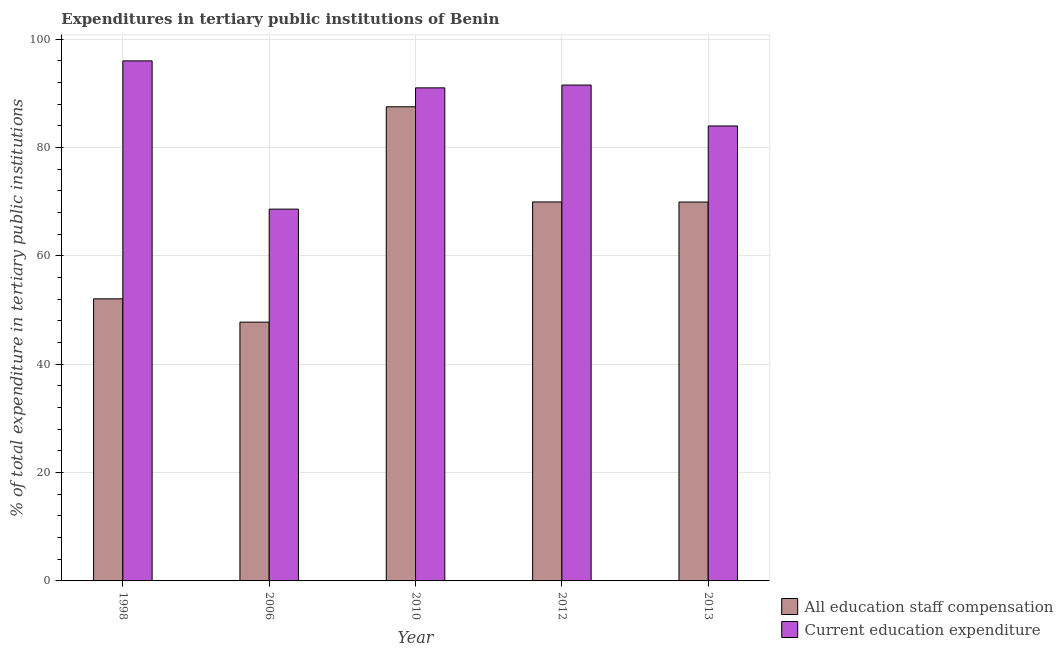How many different coloured bars are there?
Provide a short and direct response. 2. Are the number of bars per tick equal to the number of legend labels?
Provide a succinct answer. Yes. Are the number of bars on each tick of the X-axis equal?
Provide a short and direct response. Yes. In how many cases, is the number of bars for a given year not equal to the number of legend labels?
Provide a succinct answer. 0. What is the expenditure in education in 2012?
Ensure brevity in your answer.  91.56. Across all years, what is the maximum expenditure in staff compensation?
Offer a terse response. 87.55. Across all years, what is the minimum expenditure in staff compensation?
Provide a short and direct response. 47.78. In which year was the expenditure in staff compensation maximum?
Your answer should be very brief. 2010. In which year was the expenditure in staff compensation minimum?
Provide a short and direct response. 2006. What is the total expenditure in education in the graph?
Offer a very short reply. 431.26. What is the difference between the expenditure in education in 1998 and that in 2006?
Ensure brevity in your answer.  27.37. What is the difference between the expenditure in education in 2013 and the expenditure in staff compensation in 2010?
Provide a short and direct response. -7.04. What is the average expenditure in education per year?
Provide a succinct answer. 86.25. In the year 2006, what is the difference between the expenditure in education and expenditure in staff compensation?
Keep it short and to the point. 0. What is the ratio of the expenditure in staff compensation in 1998 to that in 2006?
Your response must be concise. 1.09. Is the difference between the expenditure in staff compensation in 2010 and 2012 greater than the difference between the expenditure in education in 2010 and 2012?
Offer a very short reply. No. What is the difference between the highest and the second highest expenditure in staff compensation?
Make the answer very short. 17.57. What is the difference between the highest and the lowest expenditure in education?
Give a very brief answer. 27.37. In how many years, is the expenditure in education greater than the average expenditure in education taken over all years?
Offer a terse response. 3. What does the 1st bar from the left in 2012 represents?
Make the answer very short. All education staff compensation. What does the 1st bar from the right in 2013 represents?
Provide a short and direct response. Current education expenditure. How many bars are there?
Offer a very short reply. 10. Are all the bars in the graph horizontal?
Offer a very short reply. No. How many years are there in the graph?
Your answer should be very brief. 5. What is the difference between two consecutive major ticks on the Y-axis?
Your response must be concise. 20. Does the graph contain any zero values?
Your response must be concise. No. Where does the legend appear in the graph?
Your response must be concise. Bottom right. How are the legend labels stacked?
Ensure brevity in your answer.  Vertical. What is the title of the graph?
Your answer should be very brief. Expenditures in tertiary public institutions of Benin. What is the label or title of the X-axis?
Keep it short and to the point. Year. What is the label or title of the Y-axis?
Give a very brief answer. % of total expenditure in tertiary public institutions. What is the % of total expenditure in tertiary public institutions of All education staff compensation in 1998?
Ensure brevity in your answer.  52.09. What is the % of total expenditure in tertiary public institutions of Current education expenditure in 1998?
Make the answer very short. 96.02. What is the % of total expenditure in tertiary public institutions in All education staff compensation in 2006?
Keep it short and to the point. 47.78. What is the % of total expenditure in tertiary public institutions of Current education expenditure in 2006?
Give a very brief answer. 68.65. What is the % of total expenditure in tertiary public institutions of All education staff compensation in 2010?
Keep it short and to the point. 87.55. What is the % of total expenditure in tertiary public institutions in Current education expenditure in 2010?
Offer a very short reply. 91.04. What is the % of total expenditure in tertiary public institutions in All education staff compensation in 2012?
Offer a very short reply. 69.98. What is the % of total expenditure in tertiary public institutions in Current education expenditure in 2012?
Ensure brevity in your answer.  91.56. What is the % of total expenditure in tertiary public institutions of All education staff compensation in 2013?
Make the answer very short. 69.96. What is the % of total expenditure in tertiary public institutions of Current education expenditure in 2013?
Provide a succinct answer. 84. Across all years, what is the maximum % of total expenditure in tertiary public institutions of All education staff compensation?
Your answer should be very brief. 87.55. Across all years, what is the maximum % of total expenditure in tertiary public institutions in Current education expenditure?
Ensure brevity in your answer.  96.02. Across all years, what is the minimum % of total expenditure in tertiary public institutions of All education staff compensation?
Give a very brief answer. 47.78. Across all years, what is the minimum % of total expenditure in tertiary public institutions in Current education expenditure?
Make the answer very short. 68.65. What is the total % of total expenditure in tertiary public institutions in All education staff compensation in the graph?
Your answer should be compact. 327.35. What is the total % of total expenditure in tertiary public institutions of Current education expenditure in the graph?
Make the answer very short. 431.26. What is the difference between the % of total expenditure in tertiary public institutions of All education staff compensation in 1998 and that in 2006?
Make the answer very short. 4.3. What is the difference between the % of total expenditure in tertiary public institutions in Current education expenditure in 1998 and that in 2006?
Offer a terse response. 27.37. What is the difference between the % of total expenditure in tertiary public institutions of All education staff compensation in 1998 and that in 2010?
Your response must be concise. -35.46. What is the difference between the % of total expenditure in tertiary public institutions of Current education expenditure in 1998 and that in 2010?
Your response must be concise. 4.98. What is the difference between the % of total expenditure in tertiary public institutions in All education staff compensation in 1998 and that in 2012?
Provide a succinct answer. -17.89. What is the difference between the % of total expenditure in tertiary public institutions of Current education expenditure in 1998 and that in 2012?
Keep it short and to the point. 4.47. What is the difference between the % of total expenditure in tertiary public institutions of All education staff compensation in 1998 and that in 2013?
Provide a succinct answer. -17.87. What is the difference between the % of total expenditure in tertiary public institutions of Current education expenditure in 1998 and that in 2013?
Your answer should be very brief. 12.02. What is the difference between the % of total expenditure in tertiary public institutions of All education staff compensation in 2006 and that in 2010?
Your answer should be compact. -39.76. What is the difference between the % of total expenditure in tertiary public institutions in Current education expenditure in 2006 and that in 2010?
Provide a short and direct response. -22.39. What is the difference between the % of total expenditure in tertiary public institutions in All education staff compensation in 2006 and that in 2012?
Offer a very short reply. -22.19. What is the difference between the % of total expenditure in tertiary public institutions of Current education expenditure in 2006 and that in 2012?
Provide a succinct answer. -22.91. What is the difference between the % of total expenditure in tertiary public institutions in All education staff compensation in 2006 and that in 2013?
Your response must be concise. -22.17. What is the difference between the % of total expenditure in tertiary public institutions in Current education expenditure in 2006 and that in 2013?
Offer a very short reply. -15.36. What is the difference between the % of total expenditure in tertiary public institutions of All education staff compensation in 2010 and that in 2012?
Your answer should be compact. 17.57. What is the difference between the % of total expenditure in tertiary public institutions of Current education expenditure in 2010 and that in 2012?
Offer a terse response. -0.52. What is the difference between the % of total expenditure in tertiary public institutions in All education staff compensation in 2010 and that in 2013?
Give a very brief answer. 17.59. What is the difference between the % of total expenditure in tertiary public institutions of Current education expenditure in 2010 and that in 2013?
Your response must be concise. 7.04. What is the difference between the % of total expenditure in tertiary public institutions of All education staff compensation in 2012 and that in 2013?
Provide a succinct answer. 0.02. What is the difference between the % of total expenditure in tertiary public institutions in Current education expenditure in 2012 and that in 2013?
Ensure brevity in your answer.  7.55. What is the difference between the % of total expenditure in tertiary public institutions of All education staff compensation in 1998 and the % of total expenditure in tertiary public institutions of Current education expenditure in 2006?
Provide a short and direct response. -16.56. What is the difference between the % of total expenditure in tertiary public institutions in All education staff compensation in 1998 and the % of total expenditure in tertiary public institutions in Current education expenditure in 2010?
Make the answer very short. -38.95. What is the difference between the % of total expenditure in tertiary public institutions in All education staff compensation in 1998 and the % of total expenditure in tertiary public institutions in Current education expenditure in 2012?
Give a very brief answer. -39.47. What is the difference between the % of total expenditure in tertiary public institutions in All education staff compensation in 1998 and the % of total expenditure in tertiary public institutions in Current education expenditure in 2013?
Your answer should be compact. -31.91. What is the difference between the % of total expenditure in tertiary public institutions in All education staff compensation in 2006 and the % of total expenditure in tertiary public institutions in Current education expenditure in 2010?
Give a very brief answer. -43.25. What is the difference between the % of total expenditure in tertiary public institutions of All education staff compensation in 2006 and the % of total expenditure in tertiary public institutions of Current education expenditure in 2012?
Your answer should be very brief. -43.77. What is the difference between the % of total expenditure in tertiary public institutions in All education staff compensation in 2006 and the % of total expenditure in tertiary public institutions in Current education expenditure in 2013?
Keep it short and to the point. -36.22. What is the difference between the % of total expenditure in tertiary public institutions of All education staff compensation in 2010 and the % of total expenditure in tertiary public institutions of Current education expenditure in 2012?
Offer a very short reply. -4.01. What is the difference between the % of total expenditure in tertiary public institutions of All education staff compensation in 2010 and the % of total expenditure in tertiary public institutions of Current education expenditure in 2013?
Your response must be concise. 3.54. What is the difference between the % of total expenditure in tertiary public institutions of All education staff compensation in 2012 and the % of total expenditure in tertiary public institutions of Current education expenditure in 2013?
Your answer should be compact. -14.02. What is the average % of total expenditure in tertiary public institutions in All education staff compensation per year?
Make the answer very short. 65.47. What is the average % of total expenditure in tertiary public institutions of Current education expenditure per year?
Provide a succinct answer. 86.25. In the year 1998, what is the difference between the % of total expenditure in tertiary public institutions in All education staff compensation and % of total expenditure in tertiary public institutions in Current education expenditure?
Keep it short and to the point. -43.93. In the year 2006, what is the difference between the % of total expenditure in tertiary public institutions of All education staff compensation and % of total expenditure in tertiary public institutions of Current education expenditure?
Your answer should be very brief. -20.86. In the year 2010, what is the difference between the % of total expenditure in tertiary public institutions of All education staff compensation and % of total expenditure in tertiary public institutions of Current education expenditure?
Offer a very short reply. -3.49. In the year 2012, what is the difference between the % of total expenditure in tertiary public institutions of All education staff compensation and % of total expenditure in tertiary public institutions of Current education expenditure?
Provide a short and direct response. -21.58. In the year 2013, what is the difference between the % of total expenditure in tertiary public institutions in All education staff compensation and % of total expenditure in tertiary public institutions in Current education expenditure?
Keep it short and to the point. -14.05. What is the ratio of the % of total expenditure in tertiary public institutions in All education staff compensation in 1998 to that in 2006?
Your answer should be very brief. 1.09. What is the ratio of the % of total expenditure in tertiary public institutions in Current education expenditure in 1998 to that in 2006?
Make the answer very short. 1.4. What is the ratio of the % of total expenditure in tertiary public institutions of All education staff compensation in 1998 to that in 2010?
Make the answer very short. 0.59. What is the ratio of the % of total expenditure in tertiary public institutions in Current education expenditure in 1998 to that in 2010?
Ensure brevity in your answer.  1.05. What is the ratio of the % of total expenditure in tertiary public institutions of All education staff compensation in 1998 to that in 2012?
Provide a short and direct response. 0.74. What is the ratio of the % of total expenditure in tertiary public institutions in Current education expenditure in 1998 to that in 2012?
Keep it short and to the point. 1.05. What is the ratio of the % of total expenditure in tertiary public institutions in All education staff compensation in 1998 to that in 2013?
Give a very brief answer. 0.74. What is the ratio of the % of total expenditure in tertiary public institutions in Current education expenditure in 1998 to that in 2013?
Keep it short and to the point. 1.14. What is the ratio of the % of total expenditure in tertiary public institutions in All education staff compensation in 2006 to that in 2010?
Make the answer very short. 0.55. What is the ratio of the % of total expenditure in tertiary public institutions of Current education expenditure in 2006 to that in 2010?
Ensure brevity in your answer.  0.75. What is the ratio of the % of total expenditure in tertiary public institutions of All education staff compensation in 2006 to that in 2012?
Offer a very short reply. 0.68. What is the ratio of the % of total expenditure in tertiary public institutions in Current education expenditure in 2006 to that in 2012?
Provide a succinct answer. 0.75. What is the ratio of the % of total expenditure in tertiary public institutions in All education staff compensation in 2006 to that in 2013?
Keep it short and to the point. 0.68. What is the ratio of the % of total expenditure in tertiary public institutions of Current education expenditure in 2006 to that in 2013?
Give a very brief answer. 0.82. What is the ratio of the % of total expenditure in tertiary public institutions in All education staff compensation in 2010 to that in 2012?
Ensure brevity in your answer.  1.25. What is the ratio of the % of total expenditure in tertiary public institutions of Current education expenditure in 2010 to that in 2012?
Give a very brief answer. 0.99. What is the ratio of the % of total expenditure in tertiary public institutions of All education staff compensation in 2010 to that in 2013?
Provide a short and direct response. 1.25. What is the ratio of the % of total expenditure in tertiary public institutions in Current education expenditure in 2010 to that in 2013?
Provide a short and direct response. 1.08. What is the ratio of the % of total expenditure in tertiary public institutions in All education staff compensation in 2012 to that in 2013?
Keep it short and to the point. 1. What is the ratio of the % of total expenditure in tertiary public institutions of Current education expenditure in 2012 to that in 2013?
Ensure brevity in your answer.  1.09. What is the difference between the highest and the second highest % of total expenditure in tertiary public institutions in All education staff compensation?
Offer a very short reply. 17.57. What is the difference between the highest and the second highest % of total expenditure in tertiary public institutions in Current education expenditure?
Offer a very short reply. 4.47. What is the difference between the highest and the lowest % of total expenditure in tertiary public institutions in All education staff compensation?
Make the answer very short. 39.76. What is the difference between the highest and the lowest % of total expenditure in tertiary public institutions in Current education expenditure?
Make the answer very short. 27.37. 